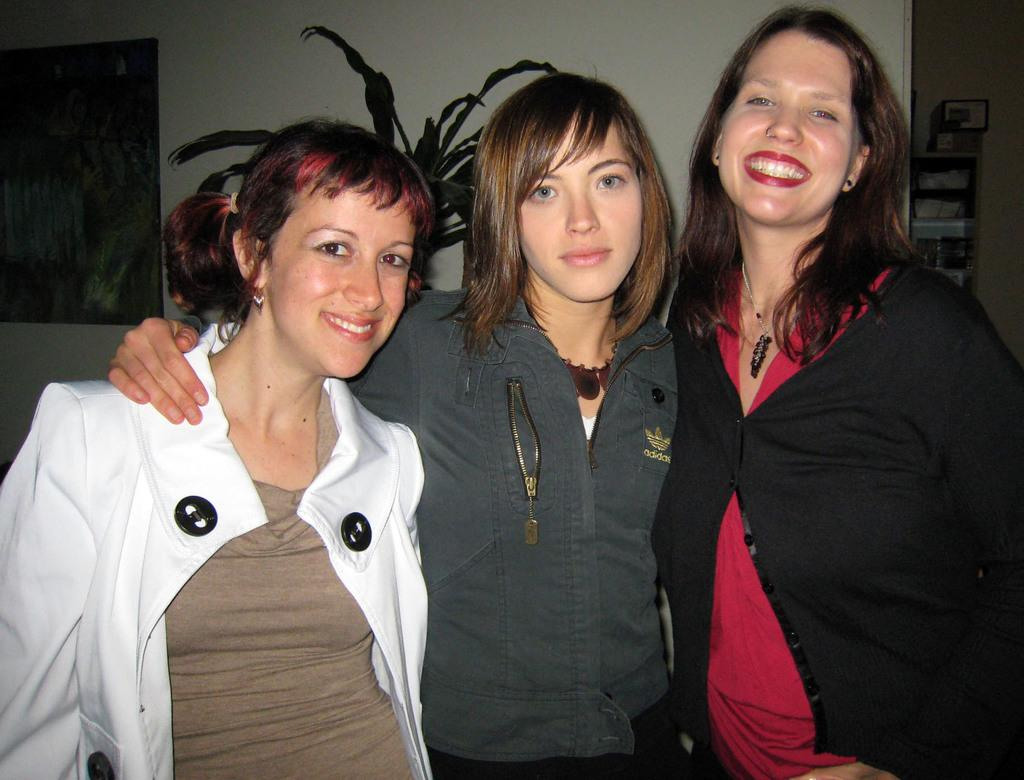How many people are present in the image? There are three ladies standing in the image. What can be seen in the background of the image? There is a plant in the background of the image. What is on the wall in the image? There is a photo frame on the wall in the image. What is the comparison between the ladies in the image? There is no comparison made between the ladies in the image; they are simply standing together. 